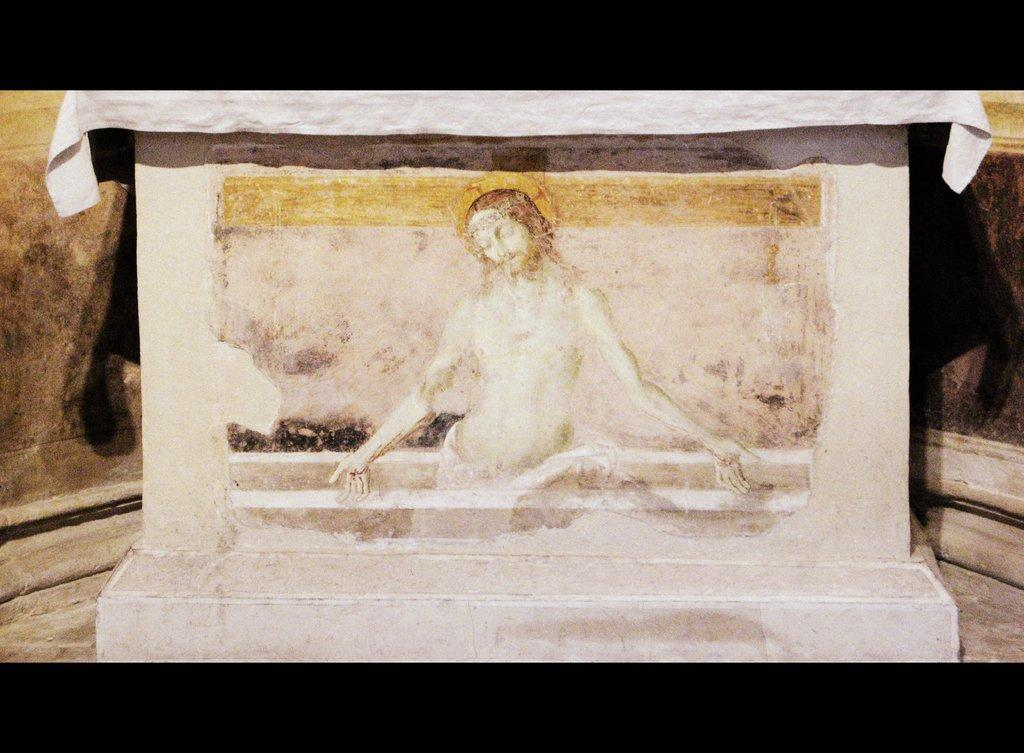What is the main subject of the image? There is a sculpture of Jesus in the image. Can you describe the sculpture in more detail? Unfortunately, the facts provided do not give any additional details about the sculpture. What is the context or setting of the image? The facts provided do not give any information about the context or setting of the image. What type of wire is used to hold the linen in the image? There is no wire or linen present in the image; it features a sculpture of Jesus. 